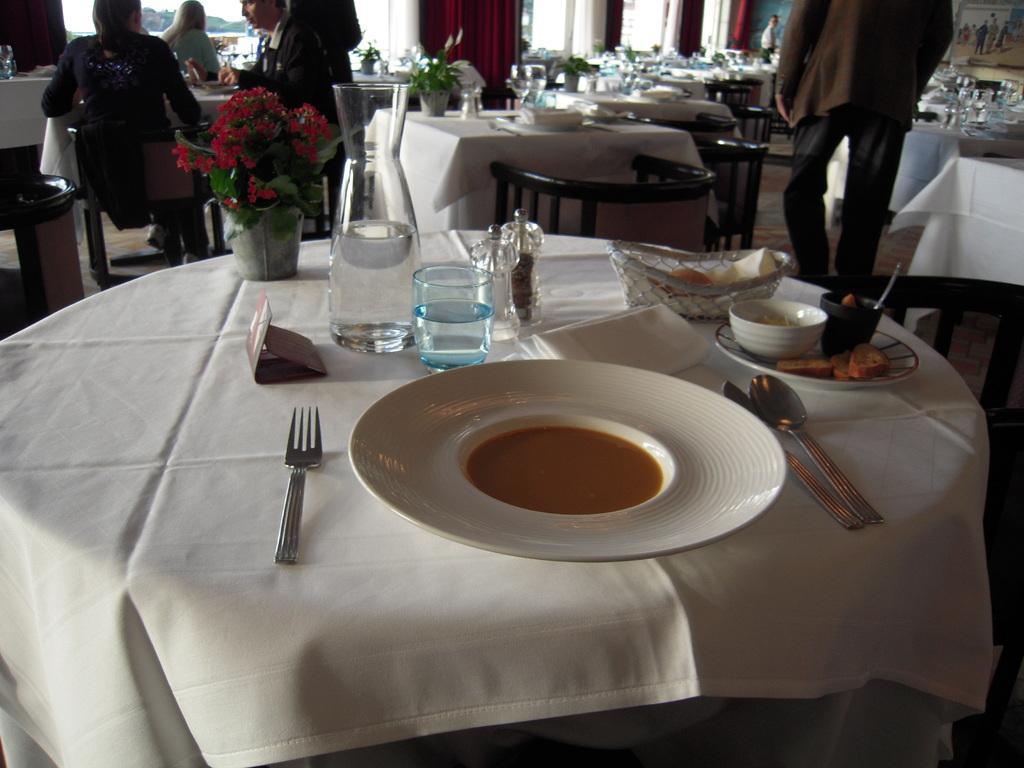How would you summarize this image in a sentence or two? In this image there are tables. On top of the tables there are plates, spoons, forks, glasses, flower pots, cups, food items. There are people sitting on the chairs. In the background of the image there are curtains. There is a glass window through which we can see trees. 